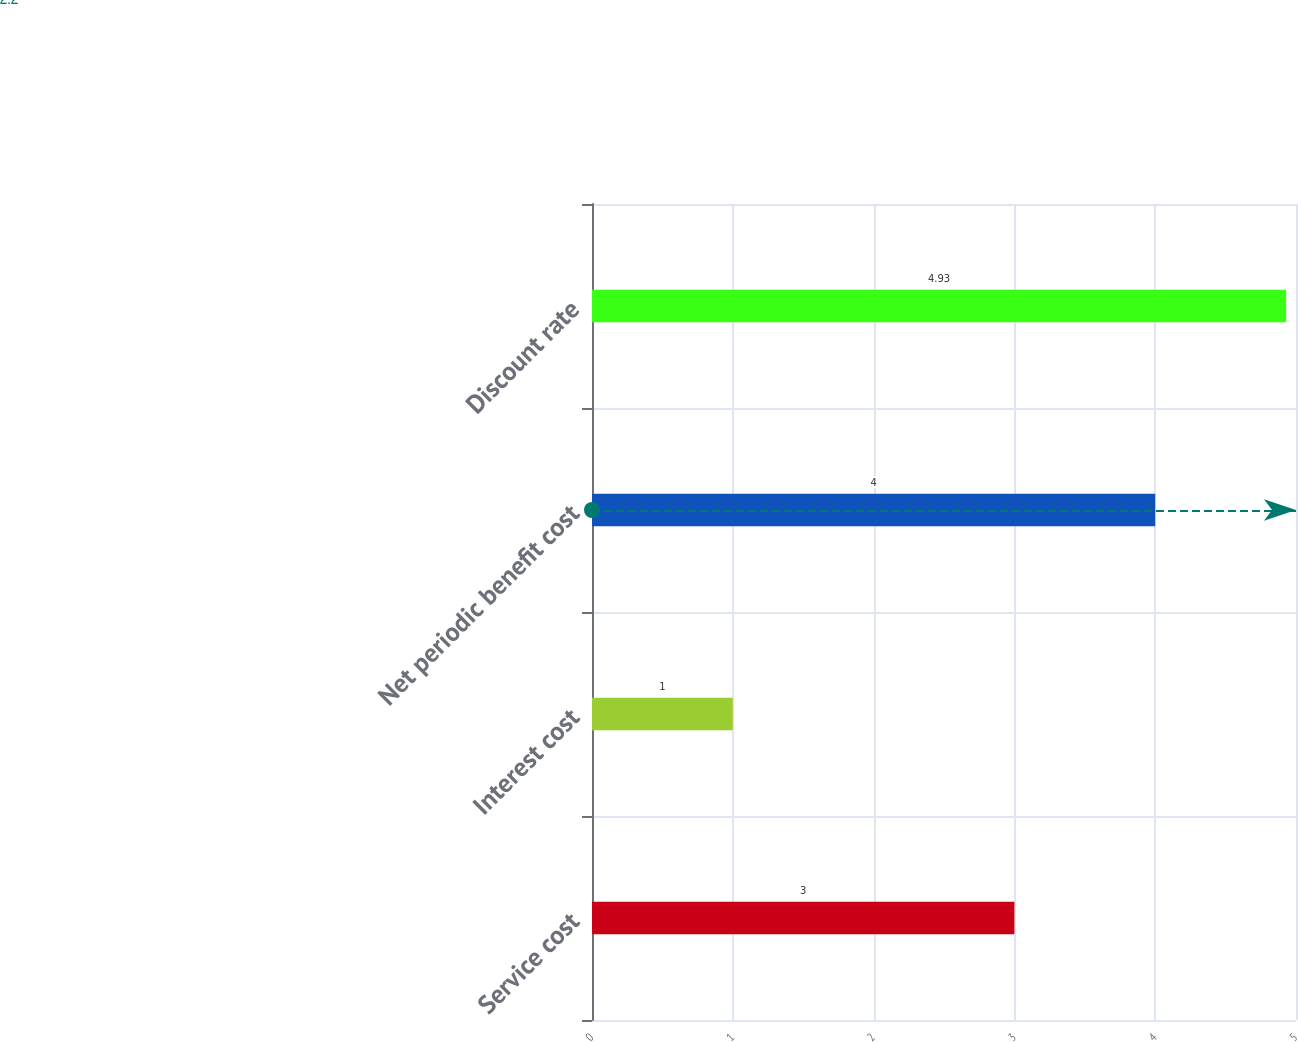<chart> <loc_0><loc_0><loc_500><loc_500><bar_chart><fcel>Service cost<fcel>Interest cost<fcel>Net periodic benefit cost<fcel>Discount rate<nl><fcel>3<fcel>1<fcel>4<fcel>4.93<nl></chart> 